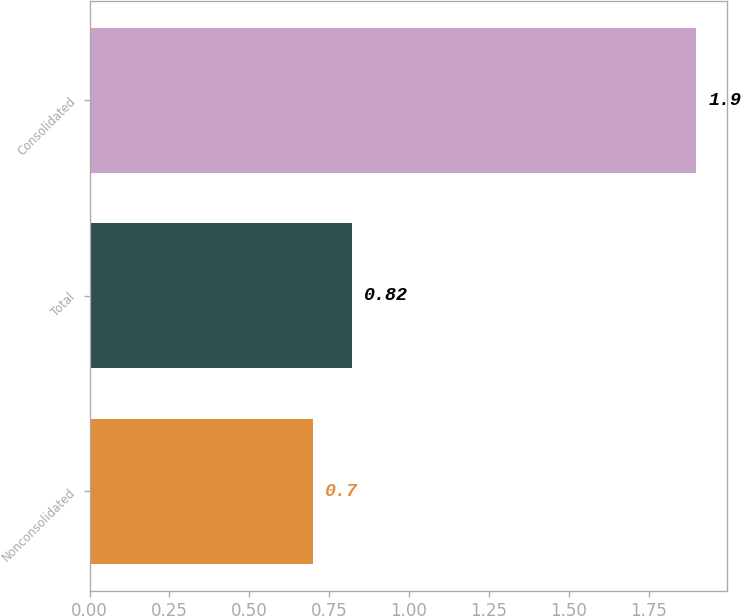Convert chart to OTSL. <chart><loc_0><loc_0><loc_500><loc_500><bar_chart><fcel>Nonconsolidated<fcel>Total<fcel>Consolidated<nl><fcel>0.7<fcel>0.82<fcel>1.9<nl></chart> 